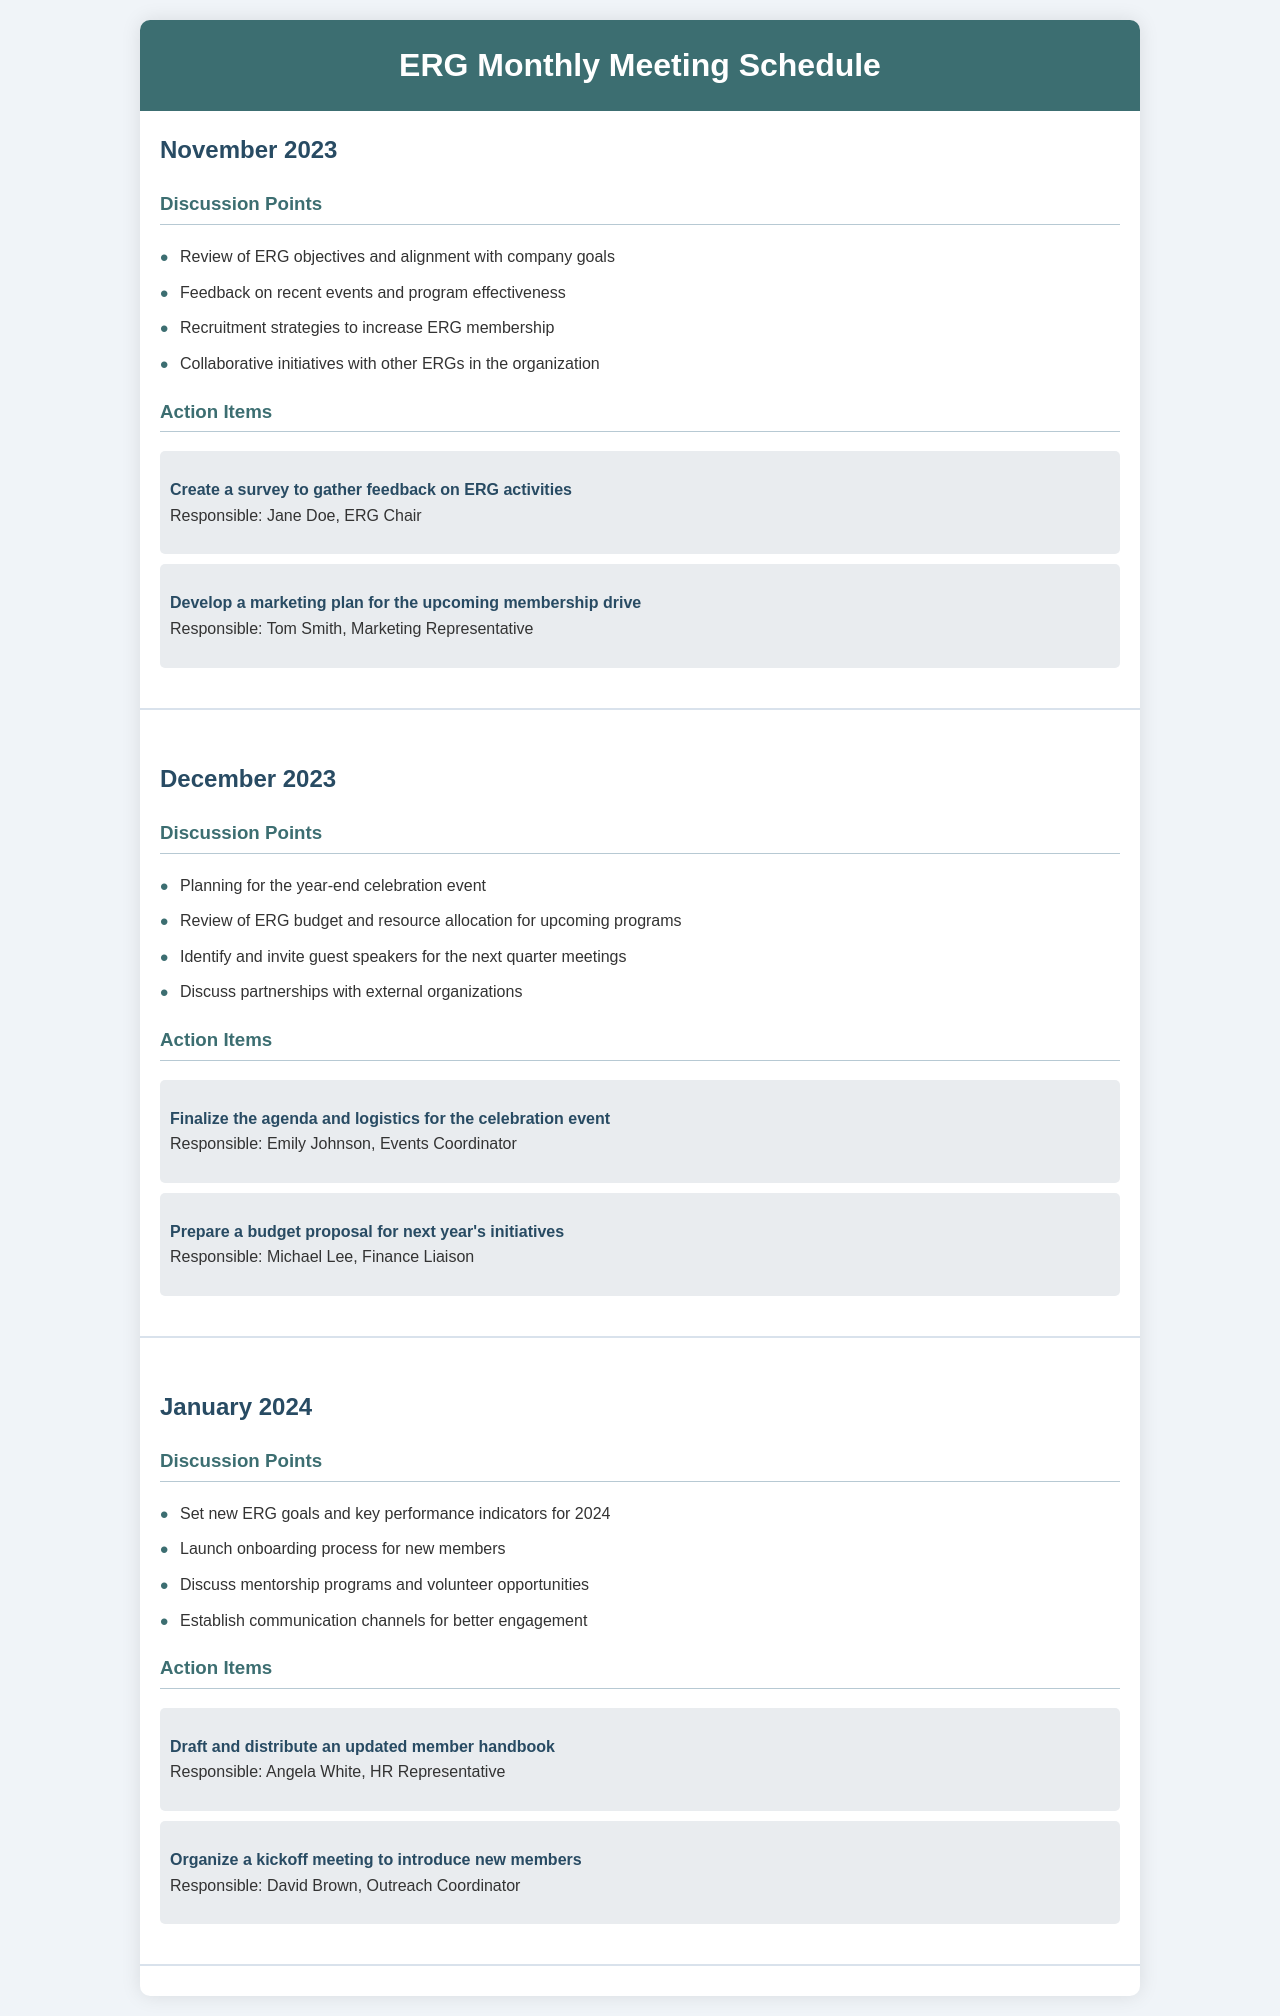What is the primary focus of the November 2023 meeting? The primary focus includes reviewing ERG objectives, gathering feedback on recent events, and discussing recruitment strategies.
Answer: Review of ERG objectives and alignment with company goals Who is responsible for creating a survey in November? The document specifies that Jane Doe is responsible for creating the survey to gather feedback.
Answer: Jane Doe How many action items are listed for December 2023? The document lists two action items for December 2023, each assigned to different individuals.
Answer: 2 What event is being planned for December 2023? The discussion point mentions planning for a celebration event at the end of the year.
Answer: Year-end celebration event What is one topic of discussion in the January 2024 meeting? The document states that setting new ERG goals for 2024 is one of the discussion points.
Answer: Set new ERG goals and key performance indicators for 2024 Who is responsible for preparing a budget proposal for next year's initiatives? Michael Lee is named as the person responsible for preparing the budget proposal in December.
Answer: Michael Lee How many total discussion points are listed for January 2024? The document outlines four discussion points for the January 2024 meeting.
Answer: 4 What is the date of the first meeting mentioned in the schedule? The first meeting is scheduled for November 2023.
Answer: November 2023 